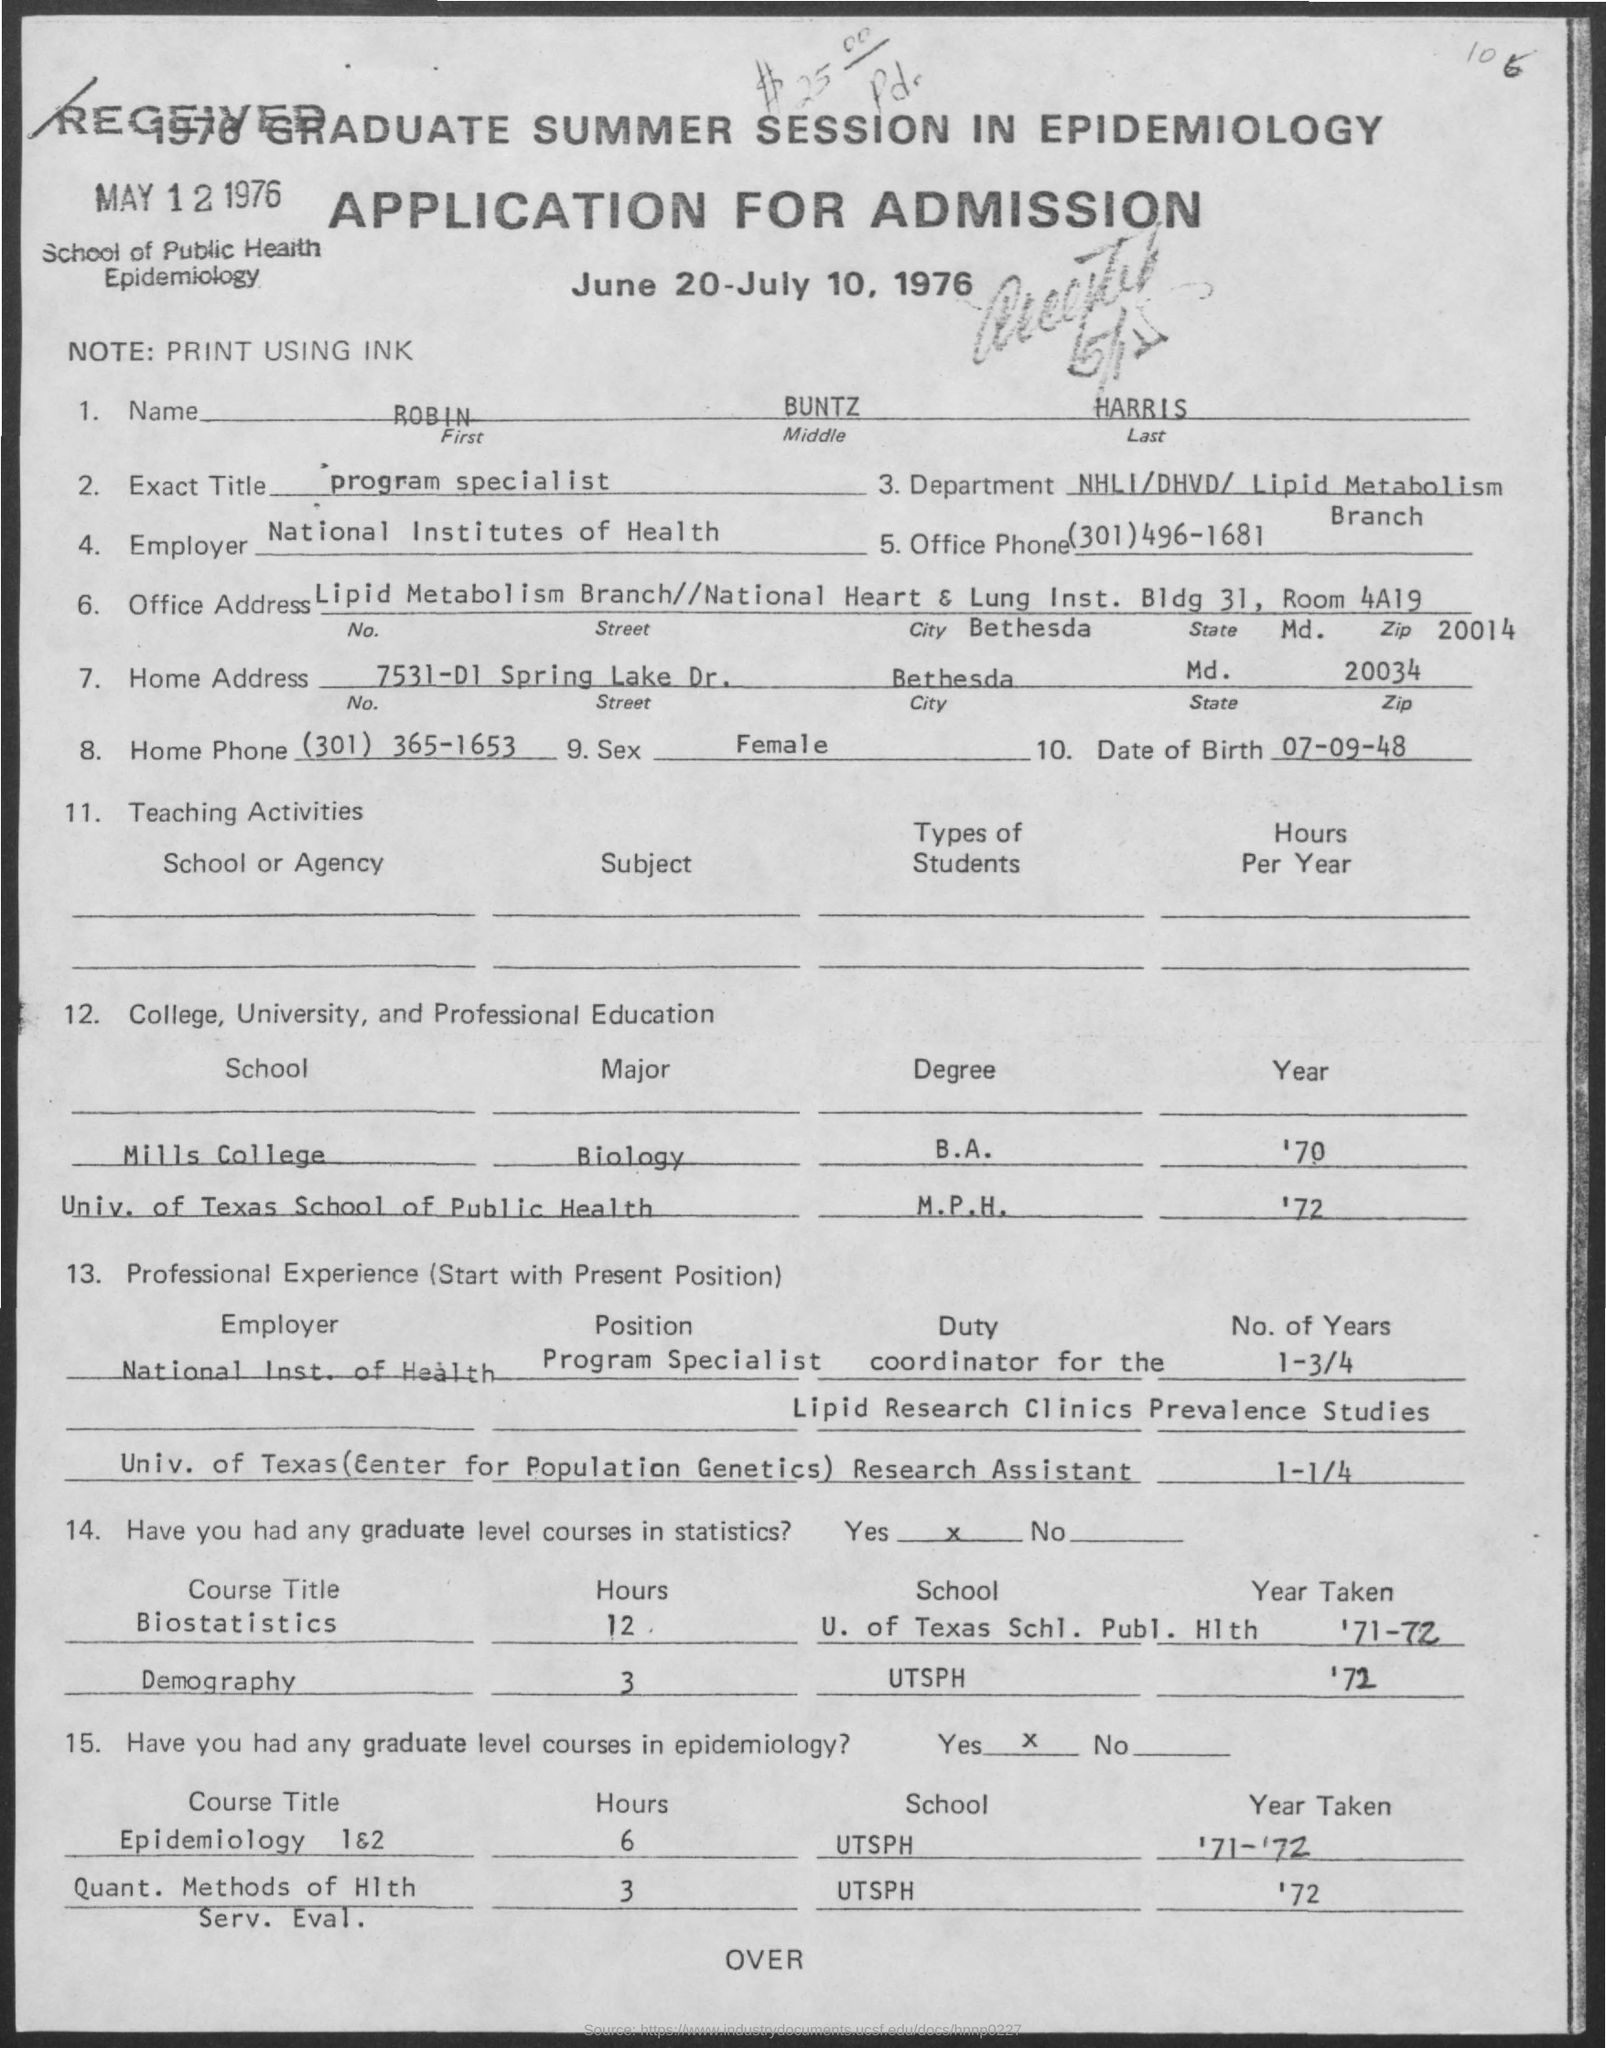Point out several critical features in this image. The date of birth of Robin is September 7, 1948. The program specialist, as written in the exact title field, is... The home phone number is (301) 365-1653. The National Institutes of Health is the employer. The note field contains text that is printed using ink. 